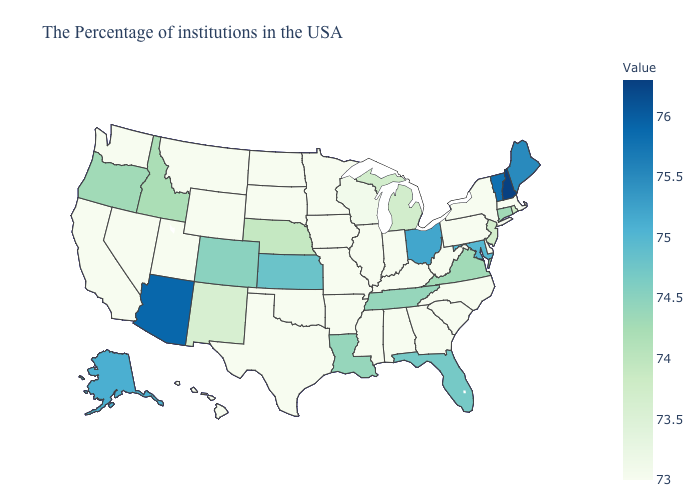Is the legend a continuous bar?
Be succinct. Yes. Does West Virginia have the lowest value in the South?
Be succinct. Yes. Among the states that border Kentucky , which have the highest value?
Write a very short answer. Ohio. Which states have the lowest value in the USA?
Answer briefly. Massachusetts, New York, Delaware, Pennsylvania, North Carolina, South Carolina, West Virginia, Georgia, Kentucky, Indiana, Alabama, Illinois, Mississippi, Missouri, Arkansas, Minnesota, Iowa, Oklahoma, Texas, South Dakota, North Dakota, Wyoming, Utah, Montana, Nevada, California, Washington, Hawaii. 